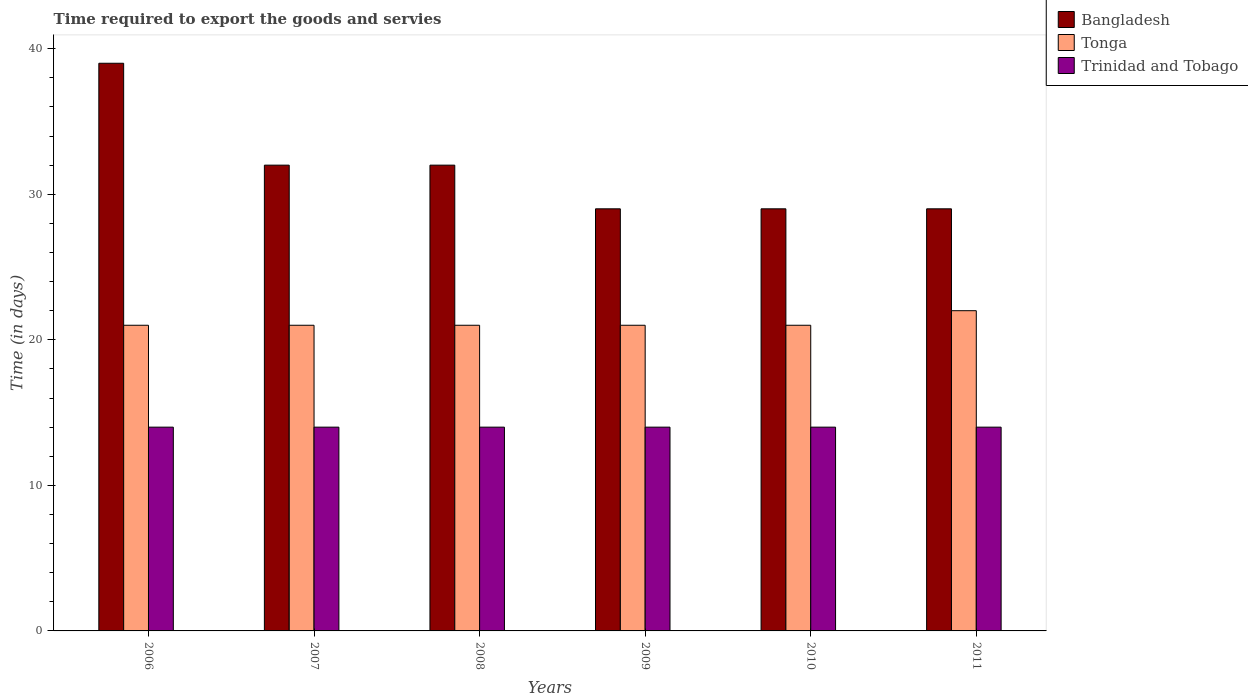Are the number of bars per tick equal to the number of legend labels?
Your response must be concise. Yes. Are the number of bars on each tick of the X-axis equal?
Your response must be concise. Yes. How many bars are there on the 4th tick from the right?
Keep it short and to the point. 3. What is the label of the 2nd group of bars from the left?
Offer a terse response. 2007. What is the number of days required to export the goods and services in Trinidad and Tobago in 2010?
Keep it short and to the point. 14. Across all years, what is the maximum number of days required to export the goods and services in Tonga?
Keep it short and to the point. 22. Across all years, what is the minimum number of days required to export the goods and services in Tonga?
Your answer should be compact. 21. In which year was the number of days required to export the goods and services in Tonga minimum?
Provide a succinct answer. 2006. What is the total number of days required to export the goods and services in Trinidad and Tobago in the graph?
Ensure brevity in your answer.  84. What is the average number of days required to export the goods and services in Trinidad and Tobago per year?
Provide a succinct answer. 14. In the year 2006, what is the difference between the number of days required to export the goods and services in Tonga and number of days required to export the goods and services in Trinidad and Tobago?
Offer a very short reply. 7. Is the difference between the number of days required to export the goods and services in Tonga in 2007 and 2011 greater than the difference between the number of days required to export the goods and services in Trinidad and Tobago in 2007 and 2011?
Provide a succinct answer. No. What is the difference between the highest and the second highest number of days required to export the goods and services in Trinidad and Tobago?
Offer a very short reply. 0. What is the difference between the highest and the lowest number of days required to export the goods and services in Tonga?
Your answer should be compact. 1. What does the 2nd bar from the left in 2010 represents?
Offer a very short reply. Tonga. What does the 2nd bar from the right in 2010 represents?
Your response must be concise. Tonga. How many bars are there?
Provide a short and direct response. 18. Are all the bars in the graph horizontal?
Offer a very short reply. No. What is the difference between two consecutive major ticks on the Y-axis?
Provide a short and direct response. 10. Does the graph contain grids?
Your answer should be very brief. No. What is the title of the graph?
Provide a short and direct response. Time required to export the goods and servies. Does "Montenegro" appear as one of the legend labels in the graph?
Give a very brief answer. No. What is the label or title of the X-axis?
Your answer should be compact. Years. What is the label or title of the Y-axis?
Provide a succinct answer. Time (in days). What is the Time (in days) of Tonga in 2006?
Your answer should be compact. 21. What is the Time (in days) in Tonga in 2007?
Your response must be concise. 21. What is the Time (in days) in Bangladesh in 2008?
Make the answer very short. 32. What is the Time (in days) in Trinidad and Tobago in 2008?
Provide a short and direct response. 14. What is the Time (in days) in Tonga in 2009?
Make the answer very short. 21. What is the Time (in days) of Bangladesh in 2010?
Give a very brief answer. 29. What is the Time (in days) of Tonga in 2010?
Your answer should be compact. 21. What is the Time (in days) of Bangladesh in 2011?
Provide a short and direct response. 29. What is the Time (in days) in Tonga in 2011?
Your answer should be very brief. 22. Across all years, what is the maximum Time (in days) of Tonga?
Your answer should be compact. 22. Across all years, what is the maximum Time (in days) in Trinidad and Tobago?
Provide a short and direct response. 14. What is the total Time (in days) of Bangladesh in the graph?
Provide a succinct answer. 190. What is the total Time (in days) in Tonga in the graph?
Make the answer very short. 127. What is the total Time (in days) in Trinidad and Tobago in the graph?
Provide a short and direct response. 84. What is the difference between the Time (in days) in Bangladesh in 2006 and that in 2007?
Your answer should be compact. 7. What is the difference between the Time (in days) of Bangladesh in 2006 and that in 2009?
Ensure brevity in your answer.  10. What is the difference between the Time (in days) of Tonga in 2006 and that in 2009?
Offer a terse response. 0. What is the difference between the Time (in days) of Bangladesh in 2006 and that in 2010?
Your response must be concise. 10. What is the difference between the Time (in days) of Tonga in 2006 and that in 2010?
Give a very brief answer. 0. What is the difference between the Time (in days) in Trinidad and Tobago in 2006 and that in 2011?
Offer a terse response. 0. What is the difference between the Time (in days) of Bangladesh in 2007 and that in 2008?
Your answer should be compact. 0. What is the difference between the Time (in days) in Tonga in 2007 and that in 2008?
Make the answer very short. 0. What is the difference between the Time (in days) in Trinidad and Tobago in 2007 and that in 2008?
Ensure brevity in your answer.  0. What is the difference between the Time (in days) in Bangladesh in 2007 and that in 2009?
Make the answer very short. 3. What is the difference between the Time (in days) in Tonga in 2007 and that in 2009?
Give a very brief answer. 0. What is the difference between the Time (in days) in Trinidad and Tobago in 2007 and that in 2009?
Make the answer very short. 0. What is the difference between the Time (in days) of Bangladesh in 2007 and that in 2011?
Keep it short and to the point. 3. What is the difference between the Time (in days) of Tonga in 2007 and that in 2011?
Give a very brief answer. -1. What is the difference between the Time (in days) of Bangladesh in 2008 and that in 2009?
Provide a succinct answer. 3. What is the difference between the Time (in days) of Tonga in 2008 and that in 2009?
Your answer should be compact. 0. What is the difference between the Time (in days) of Tonga in 2008 and that in 2010?
Your response must be concise. 0. What is the difference between the Time (in days) of Tonga in 2008 and that in 2011?
Your answer should be compact. -1. What is the difference between the Time (in days) in Trinidad and Tobago in 2008 and that in 2011?
Your response must be concise. 0. What is the difference between the Time (in days) in Bangladesh in 2009 and that in 2011?
Give a very brief answer. 0. What is the difference between the Time (in days) in Trinidad and Tobago in 2009 and that in 2011?
Ensure brevity in your answer.  0. What is the difference between the Time (in days) of Trinidad and Tobago in 2010 and that in 2011?
Offer a terse response. 0. What is the difference between the Time (in days) of Bangladesh in 2006 and the Time (in days) of Trinidad and Tobago in 2007?
Your response must be concise. 25. What is the difference between the Time (in days) in Bangladesh in 2006 and the Time (in days) in Trinidad and Tobago in 2008?
Provide a short and direct response. 25. What is the difference between the Time (in days) of Bangladesh in 2006 and the Time (in days) of Tonga in 2009?
Offer a terse response. 18. What is the difference between the Time (in days) of Tonga in 2006 and the Time (in days) of Trinidad and Tobago in 2009?
Provide a succinct answer. 7. What is the difference between the Time (in days) of Tonga in 2006 and the Time (in days) of Trinidad and Tobago in 2010?
Provide a succinct answer. 7. What is the difference between the Time (in days) of Bangladesh in 2006 and the Time (in days) of Trinidad and Tobago in 2011?
Give a very brief answer. 25. What is the difference between the Time (in days) in Bangladesh in 2007 and the Time (in days) in Trinidad and Tobago in 2008?
Keep it short and to the point. 18. What is the difference between the Time (in days) in Tonga in 2007 and the Time (in days) in Trinidad and Tobago in 2008?
Make the answer very short. 7. What is the difference between the Time (in days) in Bangladesh in 2007 and the Time (in days) in Tonga in 2009?
Offer a very short reply. 11. What is the difference between the Time (in days) of Bangladesh in 2007 and the Time (in days) of Trinidad and Tobago in 2009?
Offer a very short reply. 18. What is the difference between the Time (in days) of Tonga in 2007 and the Time (in days) of Trinidad and Tobago in 2009?
Provide a short and direct response. 7. What is the difference between the Time (in days) in Bangladesh in 2007 and the Time (in days) in Tonga in 2010?
Offer a very short reply. 11. What is the difference between the Time (in days) in Bangladesh in 2007 and the Time (in days) in Trinidad and Tobago in 2010?
Offer a terse response. 18. What is the difference between the Time (in days) in Bangladesh in 2007 and the Time (in days) in Tonga in 2011?
Ensure brevity in your answer.  10. What is the difference between the Time (in days) of Bangladesh in 2007 and the Time (in days) of Trinidad and Tobago in 2011?
Keep it short and to the point. 18. What is the difference between the Time (in days) in Bangladesh in 2008 and the Time (in days) in Trinidad and Tobago in 2009?
Offer a very short reply. 18. What is the difference between the Time (in days) in Tonga in 2008 and the Time (in days) in Trinidad and Tobago in 2009?
Offer a very short reply. 7. What is the difference between the Time (in days) of Bangladesh in 2008 and the Time (in days) of Tonga in 2010?
Your answer should be compact. 11. What is the difference between the Time (in days) in Bangladesh in 2008 and the Time (in days) in Trinidad and Tobago in 2010?
Offer a very short reply. 18. What is the difference between the Time (in days) of Tonga in 2008 and the Time (in days) of Trinidad and Tobago in 2010?
Your response must be concise. 7. What is the difference between the Time (in days) in Bangladesh in 2008 and the Time (in days) in Tonga in 2011?
Keep it short and to the point. 10. What is the difference between the Time (in days) of Bangladesh in 2008 and the Time (in days) of Trinidad and Tobago in 2011?
Your answer should be compact. 18. What is the difference between the Time (in days) in Tonga in 2009 and the Time (in days) in Trinidad and Tobago in 2011?
Your answer should be compact. 7. What is the difference between the Time (in days) in Bangladesh in 2010 and the Time (in days) in Tonga in 2011?
Give a very brief answer. 7. What is the average Time (in days) of Bangladesh per year?
Provide a succinct answer. 31.67. What is the average Time (in days) of Tonga per year?
Offer a very short reply. 21.17. In the year 2006, what is the difference between the Time (in days) in Bangladesh and Time (in days) in Trinidad and Tobago?
Your answer should be compact. 25. In the year 2007, what is the difference between the Time (in days) of Bangladesh and Time (in days) of Tonga?
Provide a succinct answer. 11. In the year 2008, what is the difference between the Time (in days) in Bangladesh and Time (in days) in Tonga?
Give a very brief answer. 11. In the year 2009, what is the difference between the Time (in days) of Tonga and Time (in days) of Trinidad and Tobago?
Your answer should be very brief. 7. In the year 2010, what is the difference between the Time (in days) of Bangladesh and Time (in days) of Tonga?
Make the answer very short. 8. In the year 2010, what is the difference between the Time (in days) in Bangladesh and Time (in days) in Trinidad and Tobago?
Give a very brief answer. 15. In the year 2010, what is the difference between the Time (in days) of Tonga and Time (in days) of Trinidad and Tobago?
Give a very brief answer. 7. What is the ratio of the Time (in days) in Bangladesh in 2006 to that in 2007?
Keep it short and to the point. 1.22. What is the ratio of the Time (in days) of Bangladesh in 2006 to that in 2008?
Provide a succinct answer. 1.22. What is the ratio of the Time (in days) of Tonga in 2006 to that in 2008?
Offer a terse response. 1. What is the ratio of the Time (in days) in Trinidad and Tobago in 2006 to that in 2008?
Provide a succinct answer. 1. What is the ratio of the Time (in days) in Bangladesh in 2006 to that in 2009?
Give a very brief answer. 1.34. What is the ratio of the Time (in days) of Tonga in 2006 to that in 2009?
Offer a terse response. 1. What is the ratio of the Time (in days) of Trinidad and Tobago in 2006 to that in 2009?
Your answer should be compact. 1. What is the ratio of the Time (in days) in Bangladesh in 2006 to that in 2010?
Offer a very short reply. 1.34. What is the ratio of the Time (in days) in Bangladesh in 2006 to that in 2011?
Your answer should be compact. 1.34. What is the ratio of the Time (in days) in Tonga in 2006 to that in 2011?
Your answer should be very brief. 0.95. What is the ratio of the Time (in days) in Bangladesh in 2007 to that in 2009?
Provide a succinct answer. 1.1. What is the ratio of the Time (in days) of Bangladesh in 2007 to that in 2010?
Offer a terse response. 1.1. What is the ratio of the Time (in days) in Tonga in 2007 to that in 2010?
Ensure brevity in your answer.  1. What is the ratio of the Time (in days) in Bangladesh in 2007 to that in 2011?
Make the answer very short. 1.1. What is the ratio of the Time (in days) in Tonga in 2007 to that in 2011?
Your answer should be very brief. 0.95. What is the ratio of the Time (in days) in Bangladesh in 2008 to that in 2009?
Your answer should be compact. 1.1. What is the ratio of the Time (in days) of Trinidad and Tobago in 2008 to that in 2009?
Provide a short and direct response. 1. What is the ratio of the Time (in days) in Bangladesh in 2008 to that in 2010?
Provide a succinct answer. 1.1. What is the ratio of the Time (in days) of Tonga in 2008 to that in 2010?
Provide a succinct answer. 1. What is the ratio of the Time (in days) of Bangladesh in 2008 to that in 2011?
Your answer should be compact. 1.1. What is the ratio of the Time (in days) in Tonga in 2008 to that in 2011?
Your answer should be compact. 0.95. What is the ratio of the Time (in days) in Bangladesh in 2009 to that in 2010?
Make the answer very short. 1. What is the ratio of the Time (in days) in Tonga in 2009 to that in 2010?
Provide a succinct answer. 1. What is the ratio of the Time (in days) of Bangladesh in 2009 to that in 2011?
Make the answer very short. 1. What is the ratio of the Time (in days) of Tonga in 2009 to that in 2011?
Offer a very short reply. 0.95. What is the ratio of the Time (in days) of Trinidad and Tobago in 2009 to that in 2011?
Provide a succinct answer. 1. What is the ratio of the Time (in days) in Tonga in 2010 to that in 2011?
Your answer should be very brief. 0.95. What is the difference between the highest and the second highest Time (in days) of Tonga?
Your response must be concise. 1. What is the difference between the highest and the second highest Time (in days) in Trinidad and Tobago?
Ensure brevity in your answer.  0. What is the difference between the highest and the lowest Time (in days) in Tonga?
Offer a terse response. 1. 